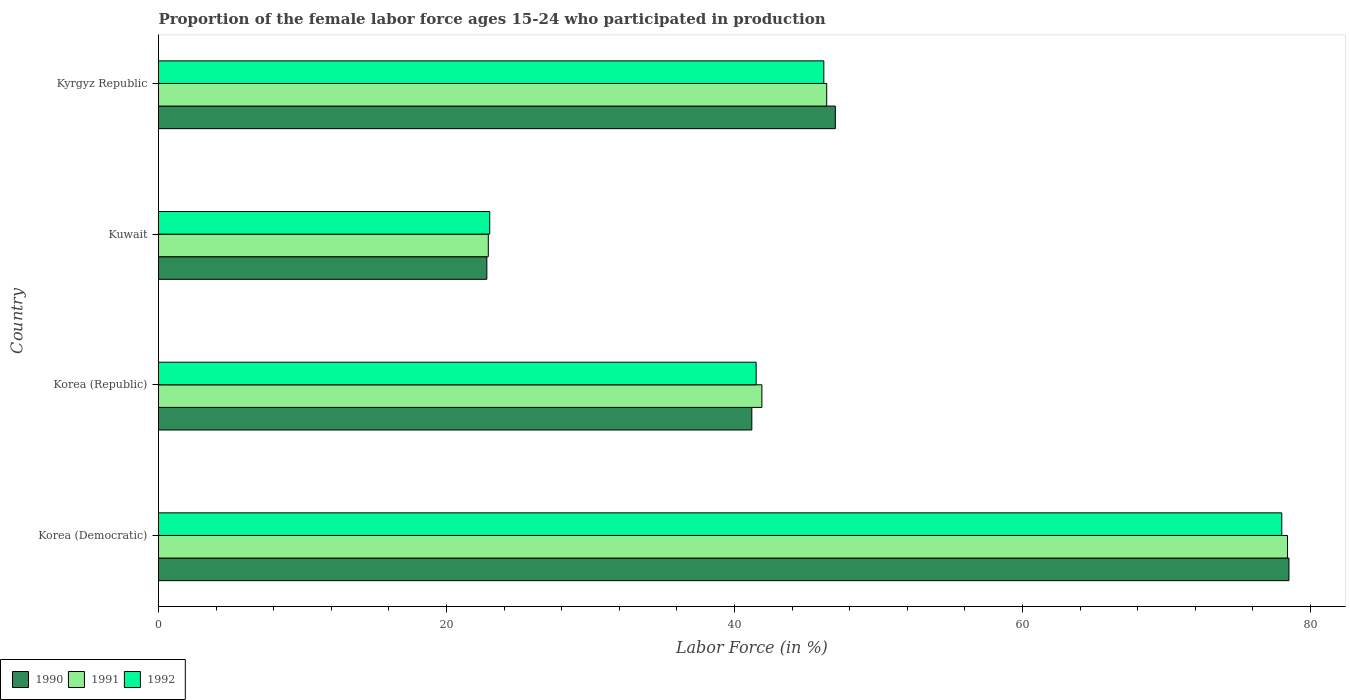How many different coloured bars are there?
Ensure brevity in your answer.  3. How many groups of bars are there?
Offer a very short reply. 4. How many bars are there on the 3rd tick from the top?
Provide a succinct answer. 3. What is the label of the 2nd group of bars from the top?
Provide a succinct answer. Kuwait. In how many cases, is the number of bars for a given country not equal to the number of legend labels?
Your response must be concise. 0. What is the proportion of the female labor force who participated in production in 1990 in Korea (Republic)?
Provide a succinct answer. 41.2. Across all countries, what is the minimum proportion of the female labor force who participated in production in 1990?
Give a very brief answer. 22.8. In which country was the proportion of the female labor force who participated in production in 1990 maximum?
Provide a succinct answer. Korea (Democratic). In which country was the proportion of the female labor force who participated in production in 1992 minimum?
Your answer should be very brief. Kuwait. What is the total proportion of the female labor force who participated in production in 1990 in the graph?
Offer a very short reply. 189.5. What is the difference between the proportion of the female labor force who participated in production in 1990 in Korea (Democratic) and that in Kyrgyz Republic?
Keep it short and to the point. 31.5. What is the difference between the proportion of the female labor force who participated in production in 1991 in Kyrgyz Republic and the proportion of the female labor force who participated in production in 1990 in Korea (Republic)?
Your answer should be compact. 5.2. What is the average proportion of the female labor force who participated in production in 1990 per country?
Your answer should be very brief. 47.38. What is the difference between the proportion of the female labor force who participated in production in 1992 and proportion of the female labor force who participated in production in 1991 in Korea (Republic)?
Give a very brief answer. -0.4. What is the ratio of the proportion of the female labor force who participated in production in 1990 in Korea (Republic) to that in Kuwait?
Provide a short and direct response. 1.81. Is the proportion of the female labor force who participated in production in 1991 in Korea (Republic) less than that in Kuwait?
Your answer should be very brief. No. Is the difference between the proportion of the female labor force who participated in production in 1992 in Kuwait and Kyrgyz Republic greater than the difference between the proportion of the female labor force who participated in production in 1991 in Kuwait and Kyrgyz Republic?
Your response must be concise. Yes. What is the difference between the highest and the second highest proportion of the female labor force who participated in production in 1992?
Your answer should be compact. 31.8. What is the difference between the highest and the lowest proportion of the female labor force who participated in production in 1991?
Provide a succinct answer. 55.5. Is the sum of the proportion of the female labor force who participated in production in 1991 in Korea (Democratic) and Korea (Republic) greater than the maximum proportion of the female labor force who participated in production in 1992 across all countries?
Your answer should be compact. Yes. Is it the case that in every country, the sum of the proportion of the female labor force who participated in production in 1990 and proportion of the female labor force who participated in production in 1992 is greater than the proportion of the female labor force who participated in production in 1991?
Provide a short and direct response. Yes. How many bars are there?
Offer a terse response. 12. What is the difference between two consecutive major ticks on the X-axis?
Your answer should be very brief. 20. Are the values on the major ticks of X-axis written in scientific E-notation?
Your answer should be compact. No. What is the title of the graph?
Make the answer very short. Proportion of the female labor force ages 15-24 who participated in production. Does "2000" appear as one of the legend labels in the graph?
Your answer should be very brief. No. What is the Labor Force (in %) in 1990 in Korea (Democratic)?
Provide a short and direct response. 78.5. What is the Labor Force (in %) of 1991 in Korea (Democratic)?
Offer a terse response. 78.4. What is the Labor Force (in %) of 1992 in Korea (Democratic)?
Give a very brief answer. 78. What is the Labor Force (in %) in 1990 in Korea (Republic)?
Make the answer very short. 41.2. What is the Labor Force (in %) in 1991 in Korea (Republic)?
Make the answer very short. 41.9. What is the Labor Force (in %) in 1992 in Korea (Republic)?
Make the answer very short. 41.5. What is the Labor Force (in %) of 1990 in Kuwait?
Provide a short and direct response. 22.8. What is the Labor Force (in %) in 1991 in Kuwait?
Provide a short and direct response. 22.9. What is the Labor Force (in %) of 1991 in Kyrgyz Republic?
Keep it short and to the point. 46.4. What is the Labor Force (in %) of 1992 in Kyrgyz Republic?
Give a very brief answer. 46.2. Across all countries, what is the maximum Labor Force (in %) in 1990?
Your answer should be compact. 78.5. Across all countries, what is the maximum Labor Force (in %) in 1991?
Ensure brevity in your answer.  78.4. Across all countries, what is the maximum Labor Force (in %) in 1992?
Make the answer very short. 78. Across all countries, what is the minimum Labor Force (in %) in 1990?
Make the answer very short. 22.8. Across all countries, what is the minimum Labor Force (in %) of 1991?
Offer a very short reply. 22.9. Across all countries, what is the minimum Labor Force (in %) in 1992?
Your answer should be compact. 23. What is the total Labor Force (in %) in 1990 in the graph?
Your answer should be compact. 189.5. What is the total Labor Force (in %) of 1991 in the graph?
Keep it short and to the point. 189.6. What is the total Labor Force (in %) in 1992 in the graph?
Provide a succinct answer. 188.7. What is the difference between the Labor Force (in %) of 1990 in Korea (Democratic) and that in Korea (Republic)?
Your response must be concise. 37.3. What is the difference between the Labor Force (in %) in 1991 in Korea (Democratic) and that in Korea (Republic)?
Keep it short and to the point. 36.5. What is the difference between the Labor Force (in %) in 1992 in Korea (Democratic) and that in Korea (Republic)?
Keep it short and to the point. 36.5. What is the difference between the Labor Force (in %) in 1990 in Korea (Democratic) and that in Kuwait?
Offer a terse response. 55.7. What is the difference between the Labor Force (in %) in 1991 in Korea (Democratic) and that in Kuwait?
Your answer should be very brief. 55.5. What is the difference between the Labor Force (in %) in 1990 in Korea (Democratic) and that in Kyrgyz Republic?
Your answer should be compact. 31.5. What is the difference between the Labor Force (in %) in 1991 in Korea (Democratic) and that in Kyrgyz Republic?
Make the answer very short. 32. What is the difference between the Labor Force (in %) in 1992 in Korea (Democratic) and that in Kyrgyz Republic?
Offer a very short reply. 31.8. What is the difference between the Labor Force (in %) in 1992 in Korea (Republic) and that in Kuwait?
Offer a very short reply. 18.5. What is the difference between the Labor Force (in %) in 1991 in Korea (Republic) and that in Kyrgyz Republic?
Make the answer very short. -4.5. What is the difference between the Labor Force (in %) in 1990 in Kuwait and that in Kyrgyz Republic?
Provide a short and direct response. -24.2. What is the difference between the Labor Force (in %) in 1991 in Kuwait and that in Kyrgyz Republic?
Ensure brevity in your answer.  -23.5. What is the difference between the Labor Force (in %) in 1992 in Kuwait and that in Kyrgyz Republic?
Keep it short and to the point. -23.2. What is the difference between the Labor Force (in %) in 1990 in Korea (Democratic) and the Labor Force (in %) in 1991 in Korea (Republic)?
Offer a very short reply. 36.6. What is the difference between the Labor Force (in %) of 1990 in Korea (Democratic) and the Labor Force (in %) of 1992 in Korea (Republic)?
Provide a short and direct response. 37. What is the difference between the Labor Force (in %) in 1991 in Korea (Democratic) and the Labor Force (in %) in 1992 in Korea (Republic)?
Give a very brief answer. 36.9. What is the difference between the Labor Force (in %) in 1990 in Korea (Democratic) and the Labor Force (in %) in 1991 in Kuwait?
Provide a short and direct response. 55.6. What is the difference between the Labor Force (in %) in 1990 in Korea (Democratic) and the Labor Force (in %) in 1992 in Kuwait?
Your response must be concise. 55.5. What is the difference between the Labor Force (in %) in 1991 in Korea (Democratic) and the Labor Force (in %) in 1992 in Kuwait?
Your response must be concise. 55.4. What is the difference between the Labor Force (in %) of 1990 in Korea (Democratic) and the Labor Force (in %) of 1991 in Kyrgyz Republic?
Your answer should be compact. 32.1. What is the difference between the Labor Force (in %) of 1990 in Korea (Democratic) and the Labor Force (in %) of 1992 in Kyrgyz Republic?
Provide a succinct answer. 32.3. What is the difference between the Labor Force (in %) of 1991 in Korea (Democratic) and the Labor Force (in %) of 1992 in Kyrgyz Republic?
Ensure brevity in your answer.  32.2. What is the difference between the Labor Force (in %) of 1990 in Korea (Republic) and the Labor Force (in %) of 1991 in Kuwait?
Offer a very short reply. 18.3. What is the difference between the Labor Force (in %) of 1991 in Korea (Republic) and the Labor Force (in %) of 1992 in Kuwait?
Provide a succinct answer. 18.9. What is the difference between the Labor Force (in %) in 1990 in Korea (Republic) and the Labor Force (in %) in 1991 in Kyrgyz Republic?
Offer a very short reply. -5.2. What is the difference between the Labor Force (in %) in 1990 in Korea (Republic) and the Labor Force (in %) in 1992 in Kyrgyz Republic?
Give a very brief answer. -5. What is the difference between the Labor Force (in %) in 1991 in Korea (Republic) and the Labor Force (in %) in 1992 in Kyrgyz Republic?
Provide a short and direct response. -4.3. What is the difference between the Labor Force (in %) of 1990 in Kuwait and the Labor Force (in %) of 1991 in Kyrgyz Republic?
Give a very brief answer. -23.6. What is the difference between the Labor Force (in %) of 1990 in Kuwait and the Labor Force (in %) of 1992 in Kyrgyz Republic?
Offer a terse response. -23.4. What is the difference between the Labor Force (in %) in 1991 in Kuwait and the Labor Force (in %) in 1992 in Kyrgyz Republic?
Provide a succinct answer. -23.3. What is the average Labor Force (in %) of 1990 per country?
Make the answer very short. 47.38. What is the average Labor Force (in %) in 1991 per country?
Keep it short and to the point. 47.4. What is the average Labor Force (in %) in 1992 per country?
Provide a short and direct response. 47.17. What is the difference between the Labor Force (in %) in 1990 and Labor Force (in %) in 1991 in Korea (Democratic)?
Make the answer very short. 0.1. What is the difference between the Labor Force (in %) in 1991 and Labor Force (in %) in 1992 in Korea (Democratic)?
Make the answer very short. 0.4. What is the difference between the Labor Force (in %) in 1990 and Labor Force (in %) in 1991 in Korea (Republic)?
Give a very brief answer. -0.7. What is the difference between the Labor Force (in %) in 1990 and Labor Force (in %) in 1992 in Korea (Republic)?
Keep it short and to the point. -0.3. What is the difference between the Labor Force (in %) of 1990 and Labor Force (in %) of 1991 in Kuwait?
Make the answer very short. -0.1. What is the difference between the Labor Force (in %) of 1991 and Labor Force (in %) of 1992 in Kuwait?
Keep it short and to the point. -0.1. What is the difference between the Labor Force (in %) in 1990 and Labor Force (in %) in 1991 in Kyrgyz Republic?
Provide a short and direct response. 0.6. What is the difference between the Labor Force (in %) in 1990 and Labor Force (in %) in 1992 in Kyrgyz Republic?
Provide a short and direct response. 0.8. What is the ratio of the Labor Force (in %) of 1990 in Korea (Democratic) to that in Korea (Republic)?
Keep it short and to the point. 1.91. What is the ratio of the Labor Force (in %) of 1991 in Korea (Democratic) to that in Korea (Republic)?
Provide a short and direct response. 1.87. What is the ratio of the Labor Force (in %) in 1992 in Korea (Democratic) to that in Korea (Republic)?
Your answer should be very brief. 1.88. What is the ratio of the Labor Force (in %) in 1990 in Korea (Democratic) to that in Kuwait?
Provide a succinct answer. 3.44. What is the ratio of the Labor Force (in %) of 1991 in Korea (Democratic) to that in Kuwait?
Offer a terse response. 3.42. What is the ratio of the Labor Force (in %) of 1992 in Korea (Democratic) to that in Kuwait?
Make the answer very short. 3.39. What is the ratio of the Labor Force (in %) in 1990 in Korea (Democratic) to that in Kyrgyz Republic?
Provide a succinct answer. 1.67. What is the ratio of the Labor Force (in %) of 1991 in Korea (Democratic) to that in Kyrgyz Republic?
Your answer should be compact. 1.69. What is the ratio of the Labor Force (in %) of 1992 in Korea (Democratic) to that in Kyrgyz Republic?
Your answer should be very brief. 1.69. What is the ratio of the Labor Force (in %) in 1990 in Korea (Republic) to that in Kuwait?
Give a very brief answer. 1.81. What is the ratio of the Labor Force (in %) in 1991 in Korea (Republic) to that in Kuwait?
Your answer should be compact. 1.83. What is the ratio of the Labor Force (in %) in 1992 in Korea (Republic) to that in Kuwait?
Provide a short and direct response. 1.8. What is the ratio of the Labor Force (in %) in 1990 in Korea (Republic) to that in Kyrgyz Republic?
Provide a short and direct response. 0.88. What is the ratio of the Labor Force (in %) in 1991 in Korea (Republic) to that in Kyrgyz Republic?
Keep it short and to the point. 0.9. What is the ratio of the Labor Force (in %) in 1992 in Korea (Republic) to that in Kyrgyz Republic?
Keep it short and to the point. 0.9. What is the ratio of the Labor Force (in %) of 1990 in Kuwait to that in Kyrgyz Republic?
Your answer should be compact. 0.49. What is the ratio of the Labor Force (in %) of 1991 in Kuwait to that in Kyrgyz Republic?
Your answer should be very brief. 0.49. What is the ratio of the Labor Force (in %) of 1992 in Kuwait to that in Kyrgyz Republic?
Provide a short and direct response. 0.5. What is the difference between the highest and the second highest Labor Force (in %) of 1990?
Your answer should be very brief. 31.5. What is the difference between the highest and the second highest Labor Force (in %) in 1992?
Make the answer very short. 31.8. What is the difference between the highest and the lowest Labor Force (in %) of 1990?
Provide a succinct answer. 55.7. What is the difference between the highest and the lowest Labor Force (in %) in 1991?
Offer a terse response. 55.5. What is the difference between the highest and the lowest Labor Force (in %) of 1992?
Your answer should be very brief. 55. 